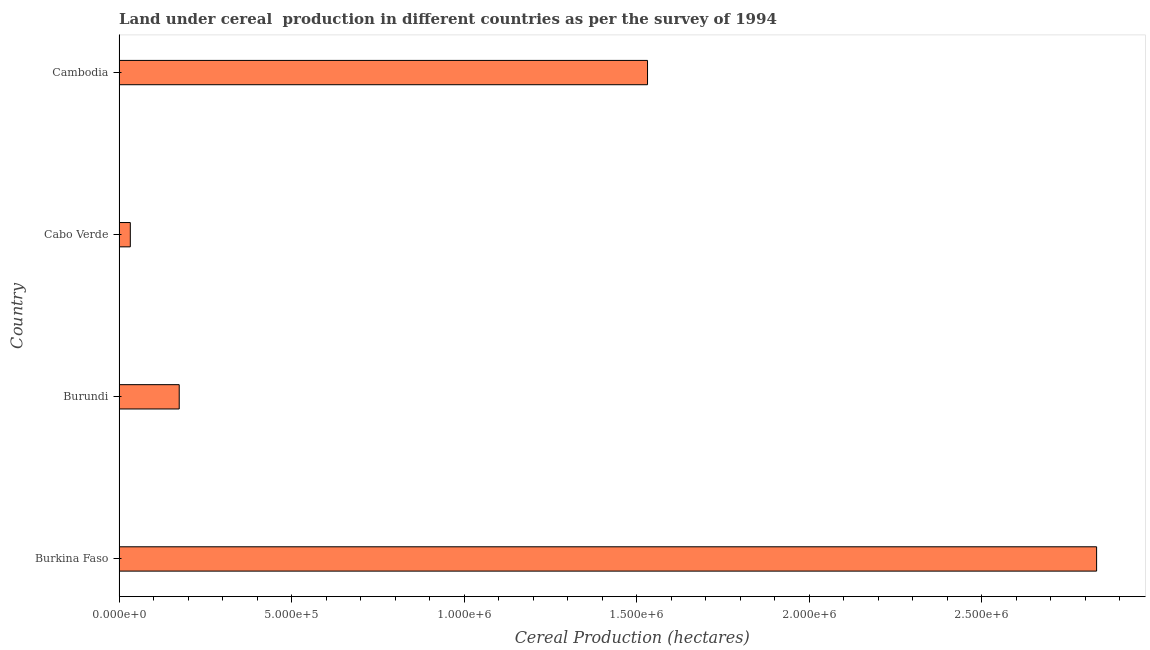Does the graph contain any zero values?
Offer a very short reply. No. Does the graph contain grids?
Ensure brevity in your answer.  No. What is the title of the graph?
Provide a short and direct response. Land under cereal  production in different countries as per the survey of 1994. What is the label or title of the X-axis?
Provide a short and direct response. Cereal Production (hectares). What is the label or title of the Y-axis?
Ensure brevity in your answer.  Country. What is the land under cereal production in Burkina Faso?
Offer a terse response. 2.83e+06. Across all countries, what is the maximum land under cereal production?
Ensure brevity in your answer.  2.83e+06. Across all countries, what is the minimum land under cereal production?
Provide a succinct answer. 3.26e+04. In which country was the land under cereal production maximum?
Your answer should be compact. Burkina Faso. In which country was the land under cereal production minimum?
Provide a succinct answer. Cabo Verde. What is the sum of the land under cereal production?
Make the answer very short. 4.57e+06. What is the difference between the land under cereal production in Burundi and Cambodia?
Give a very brief answer. -1.36e+06. What is the average land under cereal production per country?
Make the answer very short. 1.14e+06. What is the median land under cereal production?
Keep it short and to the point. 8.53e+05. What is the ratio of the land under cereal production in Burundi to that in Cabo Verde?
Offer a terse response. 5.35. Is the difference between the land under cereal production in Burkina Faso and Burundi greater than the difference between any two countries?
Offer a very short reply. No. What is the difference between the highest and the second highest land under cereal production?
Provide a succinct answer. 1.30e+06. What is the difference between the highest and the lowest land under cereal production?
Give a very brief answer. 2.80e+06. Are all the bars in the graph horizontal?
Offer a terse response. Yes. What is the Cereal Production (hectares) in Burkina Faso?
Your answer should be very brief. 2.83e+06. What is the Cereal Production (hectares) in Burundi?
Offer a terse response. 1.74e+05. What is the Cereal Production (hectares) in Cabo Verde?
Provide a succinct answer. 3.26e+04. What is the Cereal Production (hectares) in Cambodia?
Make the answer very short. 1.53e+06. What is the difference between the Cereal Production (hectares) in Burkina Faso and Burundi?
Ensure brevity in your answer.  2.66e+06. What is the difference between the Cereal Production (hectares) in Burkina Faso and Cabo Verde?
Make the answer very short. 2.80e+06. What is the difference between the Cereal Production (hectares) in Burkina Faso and Cambodia?
Ensure brevity in your answer.  1.30e+06. What is the difference between the Cereal Production (hectares) in Burundi and Cabo Verde?
Ensure brevity in your answer.  1.42e+05. What is the difference between the Cereal Production (hectares) in Burundi and Cambodia?
Your response must be concise. -1.36e+06. What is the difference between the Cereal Production (hectares) in Cabo Verde and Cambodia?
Keep it short and to the point. -1.50e+06. What is the ratio of the Cereal Production (hectares) in Burkina Faso to that in Burundi?
Give a very brief answer. 16.25. What is the ratio of the Cereal Production (hectares) in Burkina Faso to that in Cabo Verde?
Provide a short and direct response. 86.87. What is the ratio of the Cereal Production (hectares) in Burkina Faso to that in Cambodia?
Your answer should be very brief. 1.85. What is the ratio of the Cereal Production (hectares) in Burundi to that in Cabo Verde?
Offer a terse response. 5.35. What is the ratio of the Cereal Production (hectares) in Burundi to that in Cambodia?
Keep it short and to the point. 0.11. What is the ratio of the Cereal Production (hectares) in Cabo Verde to that in Cambodia?
Provide a short and direct response. 0.02. 